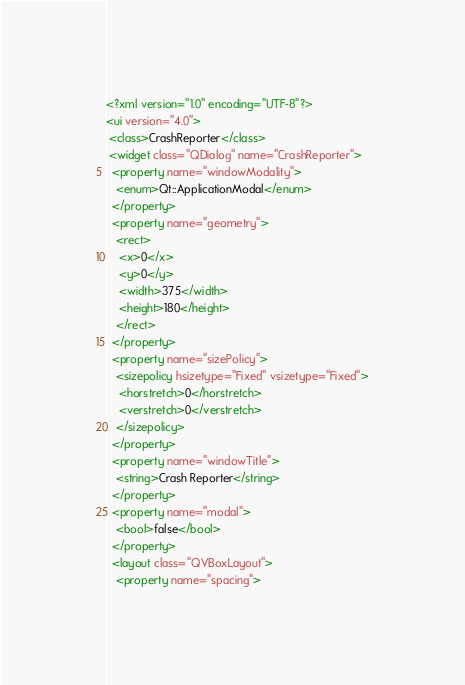<code> <loc_0><loc_0><loc_500><loc_500><_XML_><?xml version="1.0" encoding="UTF-8"?>
<ui version="4.0">
 <class>CrashReporter</class>
 <widget class="QDialog" name="CrashReporter">
  <property name="windowModality">
   <enum>Qt::ApplicationModal</enum>
  </property>
  <property name="geometry">
   <rect>
    <x>0</x>
    <y>0</y>
    <width>375</width>
    <height>180</height>
   </rect>
  </property>
  <property name="sizePolicy">
   <sizepolicy hsizetype="Fixed" vsizetype="Fixed">
    <horstretch>0</horstretch>
    <verstretch>0</verstretch>
   </sizepolicy>
  </property>
  <property name="windowTitle">
   <string>Crash Reporter</string>
  </property>
  <property name="modal">
   <bool>false</bool>
  </property>
  <layout class="QVBoxLayout">
   <property name="spacing"></code> 